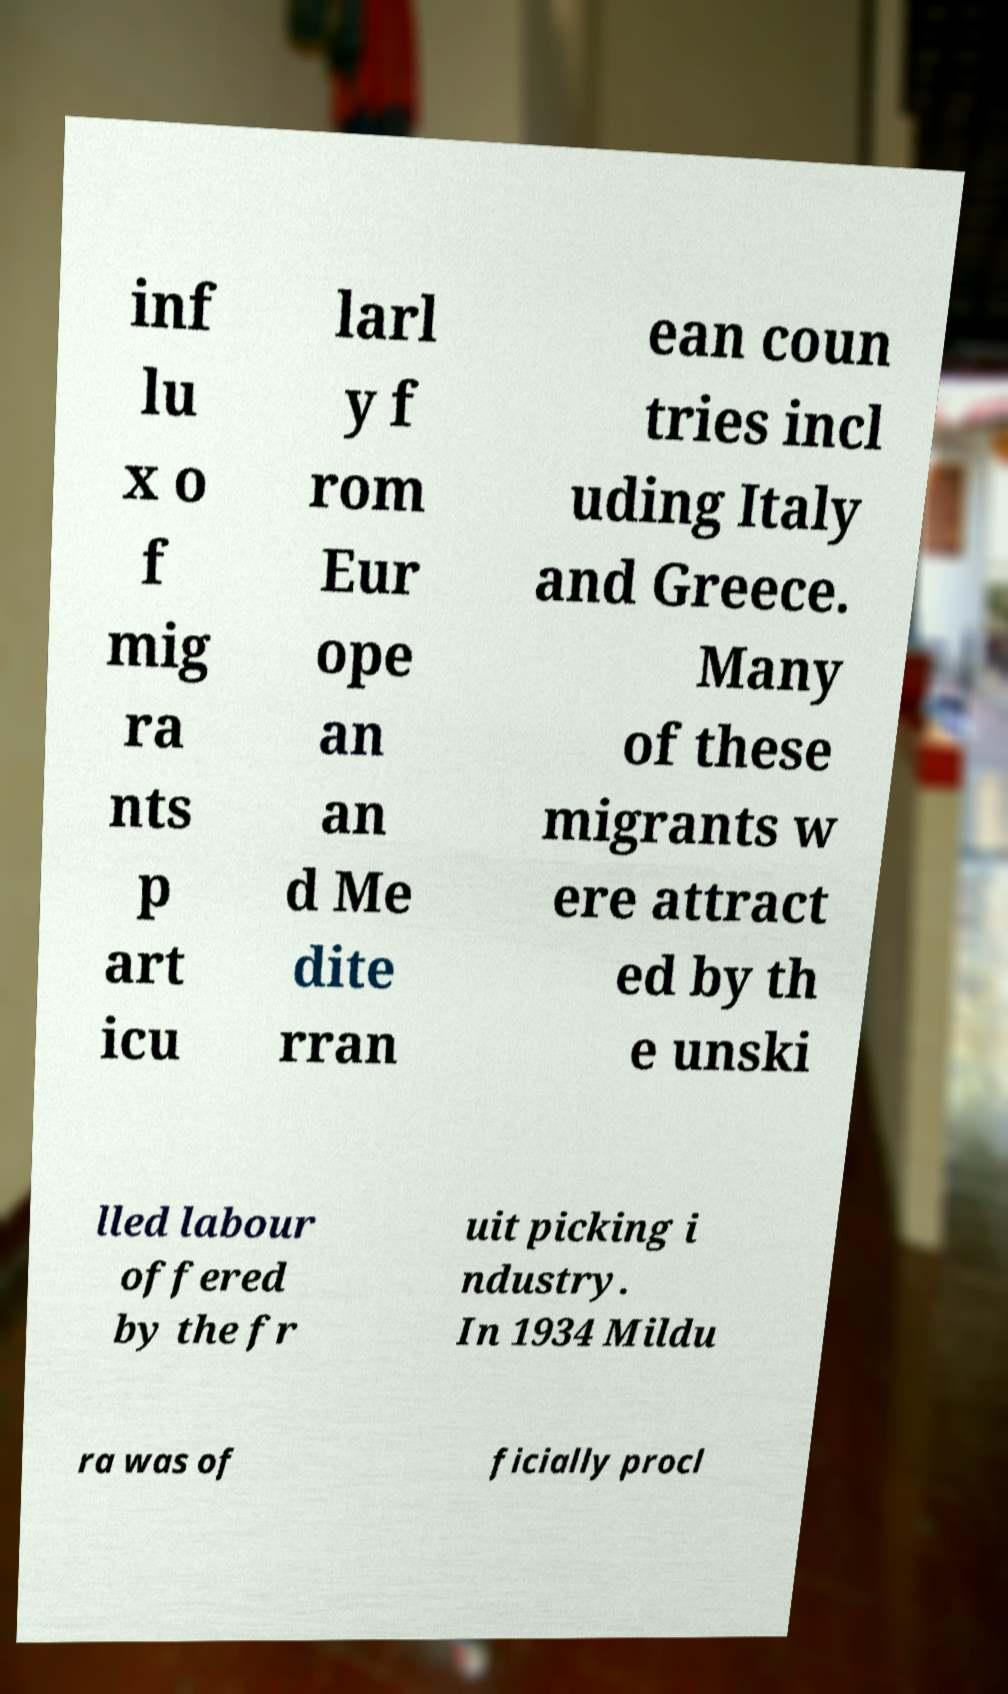Can you read and provide the text displayed in the image?This photo seems to have some interesting text. Can you extract and type it out for me? inf lu x o f mig ra nts p art icu larl y f rom Eur ope an an d Me dite rran ean coun tries incl uding Italy and Greece. Many of these migrants w ere attract ed by th e unski lled labour offered by the fr uit picking i ndustry. In 1934 Mildu ra was of ficially procl 